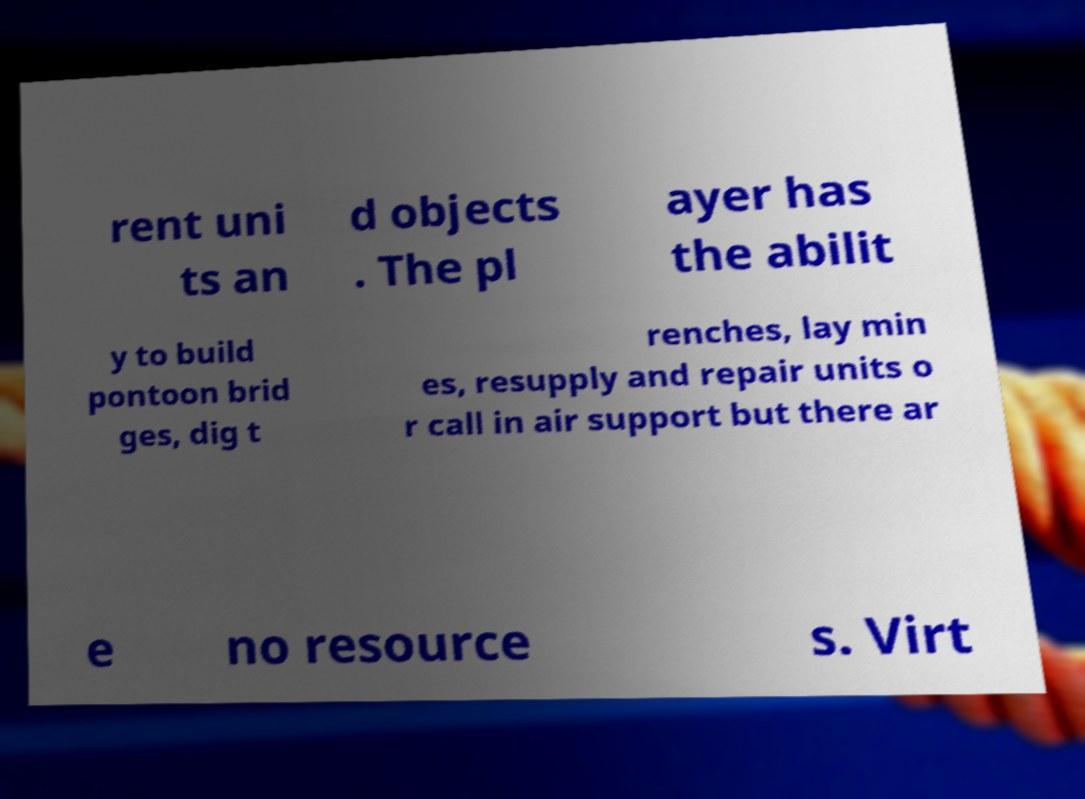What messages or text are displayed in this image? I need them in a readable, typed format. rent uni ts an d objects . The pl ayer has the abilit y to build pontoon brid ges, dig t renches, lay min es, resupply and repair units o r call in air support but there ar e no resource s. Virt 